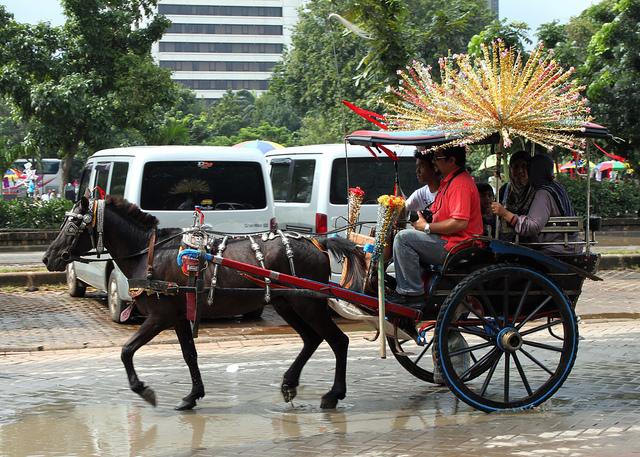Is this a rural area?
Keep it brief. No. How many white socks does the horse have?
Write a very short answer. 0. What is the horse pulling?
Answer briefly. Carriage. What is the man in pink holding?
Answer briefly. Camera. 